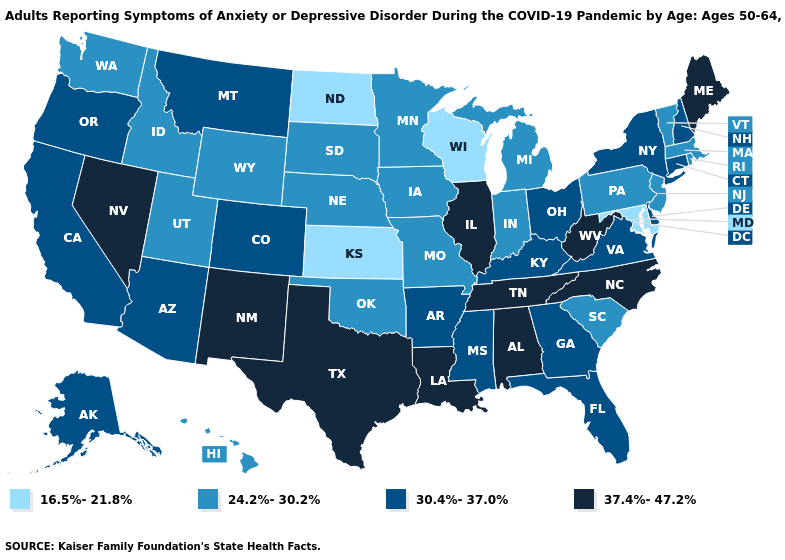What is the value of Maryland?
Keep it brief. 16.5%-21.8%. What is the value of North Dakota?
Quick response, please. 16.5%-21.8%. Which states have the lowest value in the MidWest?
Be succinct. Kansas, North Dakota, Wisconsin. Among the states that border Michigan , which have the lowest value?
Quick response, please. Wisconsin. Does the first symbol in the legend represent the smallest category?
Be succinct. Yes. Which states have the lowest value in the USA?
Keep it brief. Kansas, Maryland, North Dakota, Wisconsin. Name the states that have a value in the range 30.4%-37.0%?
Short answer required. Alaska, Arizona, Arkansas, California, Colorado, Connecticut, Delaware, Florida, Georgia, Kentucky, Mississippi, Montana, New Hampshire, New York, Ohio, Oregon, Virginia. Does New Jersey have the same value as Alabama?
Short answer required. No. What is the lowest value in the West?
Give a very brief answer. 24.2%-30.2%. Which states have the lowest value in the USA?
Write a very short answer. Kansas, Maryland, North Dakota, Wisconsin. How many symbols are there in the legend?
Give a very brief answer. 4. Name the states that have a value in the range 30.4%-37.0%?
Keep it brief. Alaska, Arizona, Arkansas, California, Colorado, Connecticut, Delaware, Florida, Georgia, Kentucky, Mississippi, Montana, New Hampshire, New York, Ohio, Oregon, Virginia. What is the value of Wyoming?
Keep it brief. 24.2%-30.2%. What is the highest value in states that border South Carolina?
Write a very short answer. 37.4%-47.2%. Is the legend a continuous bar?
Keep it brief. No. 